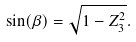<formula> <loc_0><loc_0><loc_500><loc_500>\sin ( \beta ) = { \sqrt { 1 - Z _ { 3 } ^ { 2 } } } .</formula> 